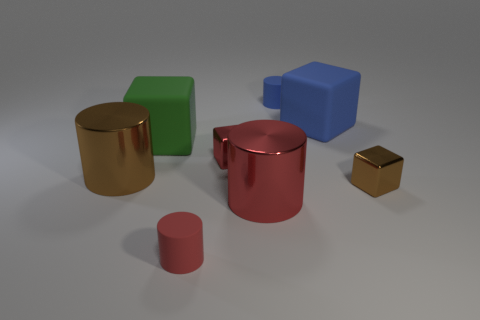Are any tiny matte balls visible?
Offer a terse response. No. What color is the block that is to the right of the tiny blue thing and in front of the blue rubber block?
Provide a succinct answer. Brown. Do the metal cylinder that is right of the red rubber cylinder and the rubber cylinder in front of the brown metallic block have the same size?
Provide a short and direct response. No. How many other objects are there of the same size as the brown metallic cube?
Your answer should be compact. 3. There is a metal thing in front of the small brown cube; how many matte blocks are on the right side of it?
Your response must be concise. 1. Are there fewer blue matte things in front of the small brown shiny cube than objects?
Your answer should be compact. Yes. What shape is the large object on the right side of the big metallic cylinder that is in front of the tiny metallic cube that is right of the tiny blue matte object?
Keep it short and to the point. Cube. Do the green rubber object and the big red thing have the same shape?
Ensure brevity in your answer.  No. How many other objects are there of the same shape as the tiny brown thing?
Your answer should be very brief. 3. What color is the other cylinder that is the same size as the red rubber cylinder?
Your response must be concise. Blue. 